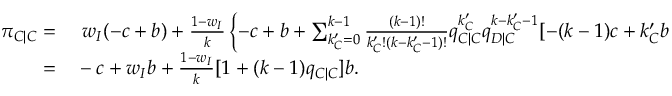<formula> <loc_0><loc_0><loc_500><loc_500>\begin{array} { r l } { \pi _ { C | C } = } & w _ { I } ( - c + b ) + \frac { 1 - w _ { I } } { k } \left \{ - c + b + \sum _ { k _ { C } ^ { \prime } = 0 } ^ { k - 1 } { \frac { ( k - 1 ) ! } { k _ { C } ^ { \prime } ! ( k - k _ { C } ^ { \prime } - 1 ) ! } q _ { C | C } ^ { k _ { C } ^ { \prime } } q _ { D | C } ^ { k - k _ { C } ^ { \prime } - 1 } [ - ( k - 1 ) c + k _ { C } ^ { \prime } b ] } \right \} } \\ { = } & - c + w _ { I } b + \frac { 1 - w _ { I } } { k } [ 1 + ( k - 1 ) q _ { C | C } ] b . } \end{array}</formula> 